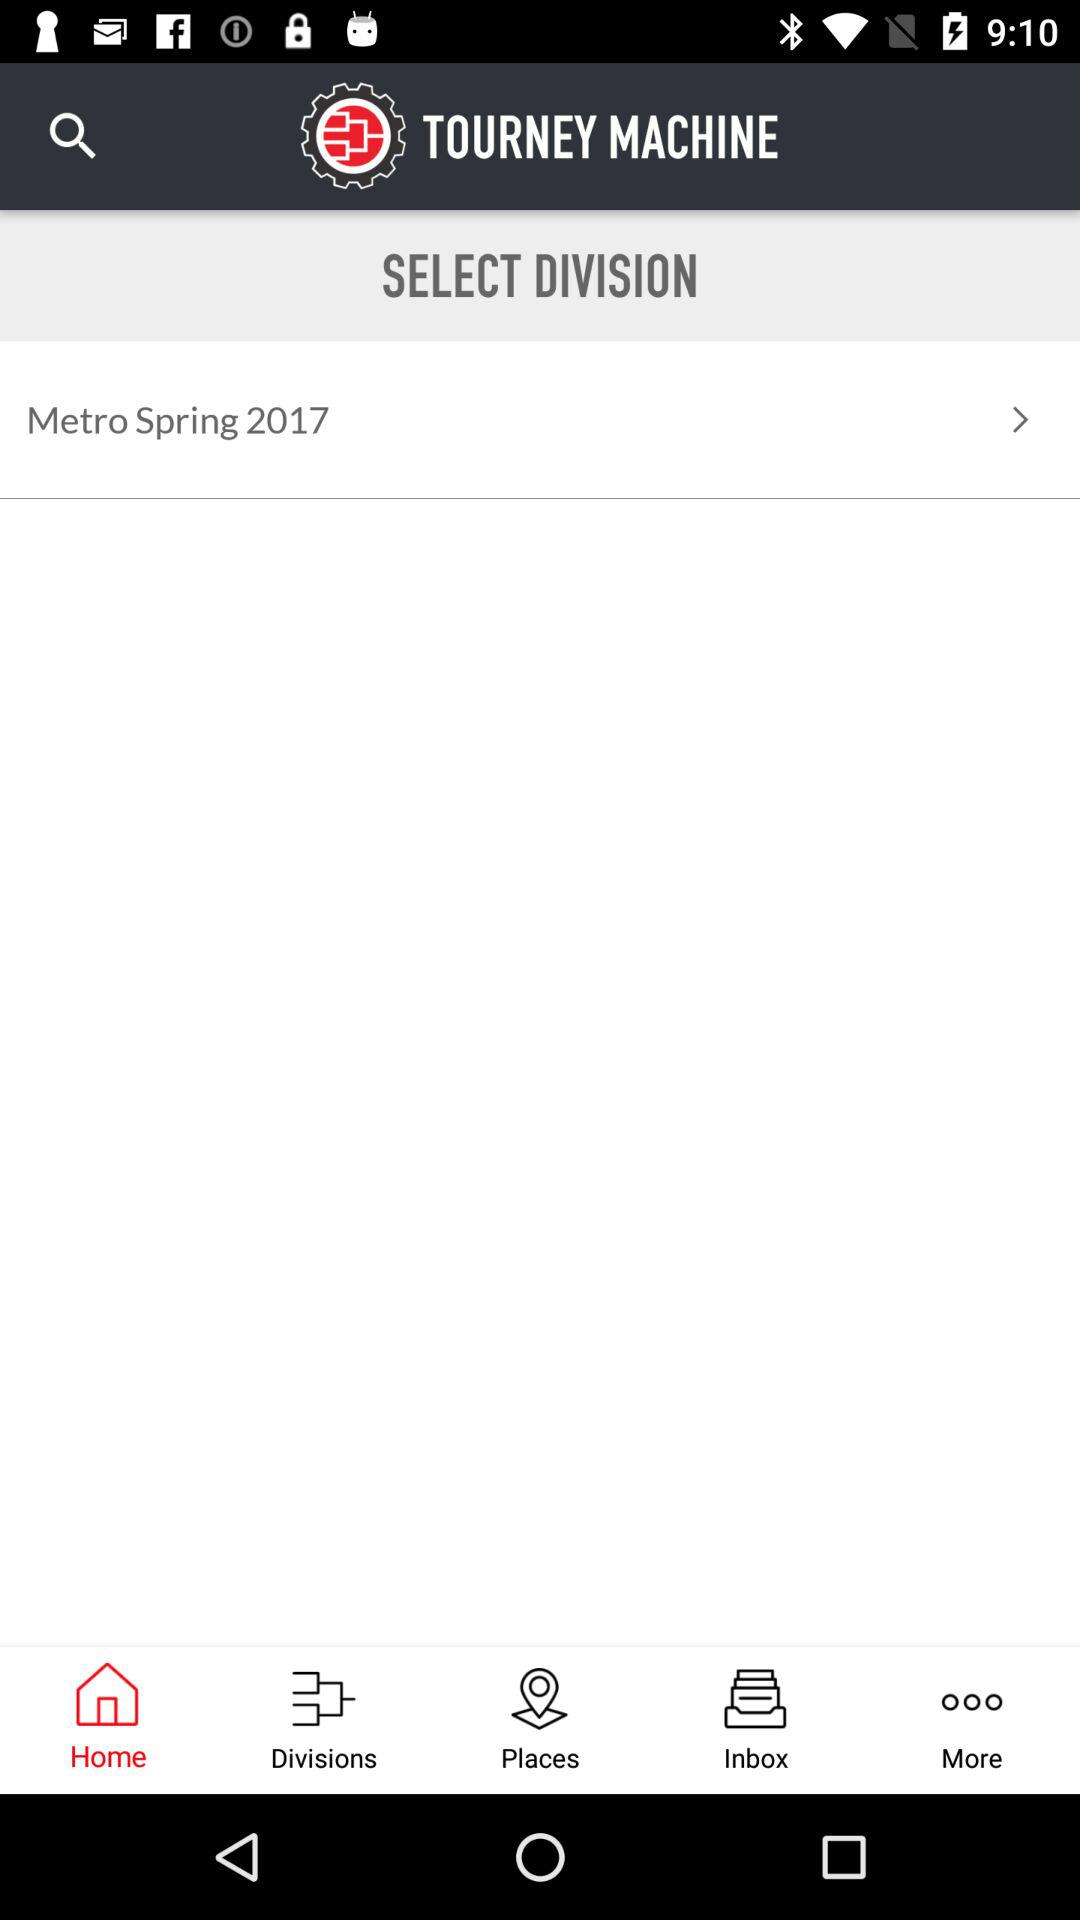What is the selected division? The selected division is "Metro Spring 2017". 